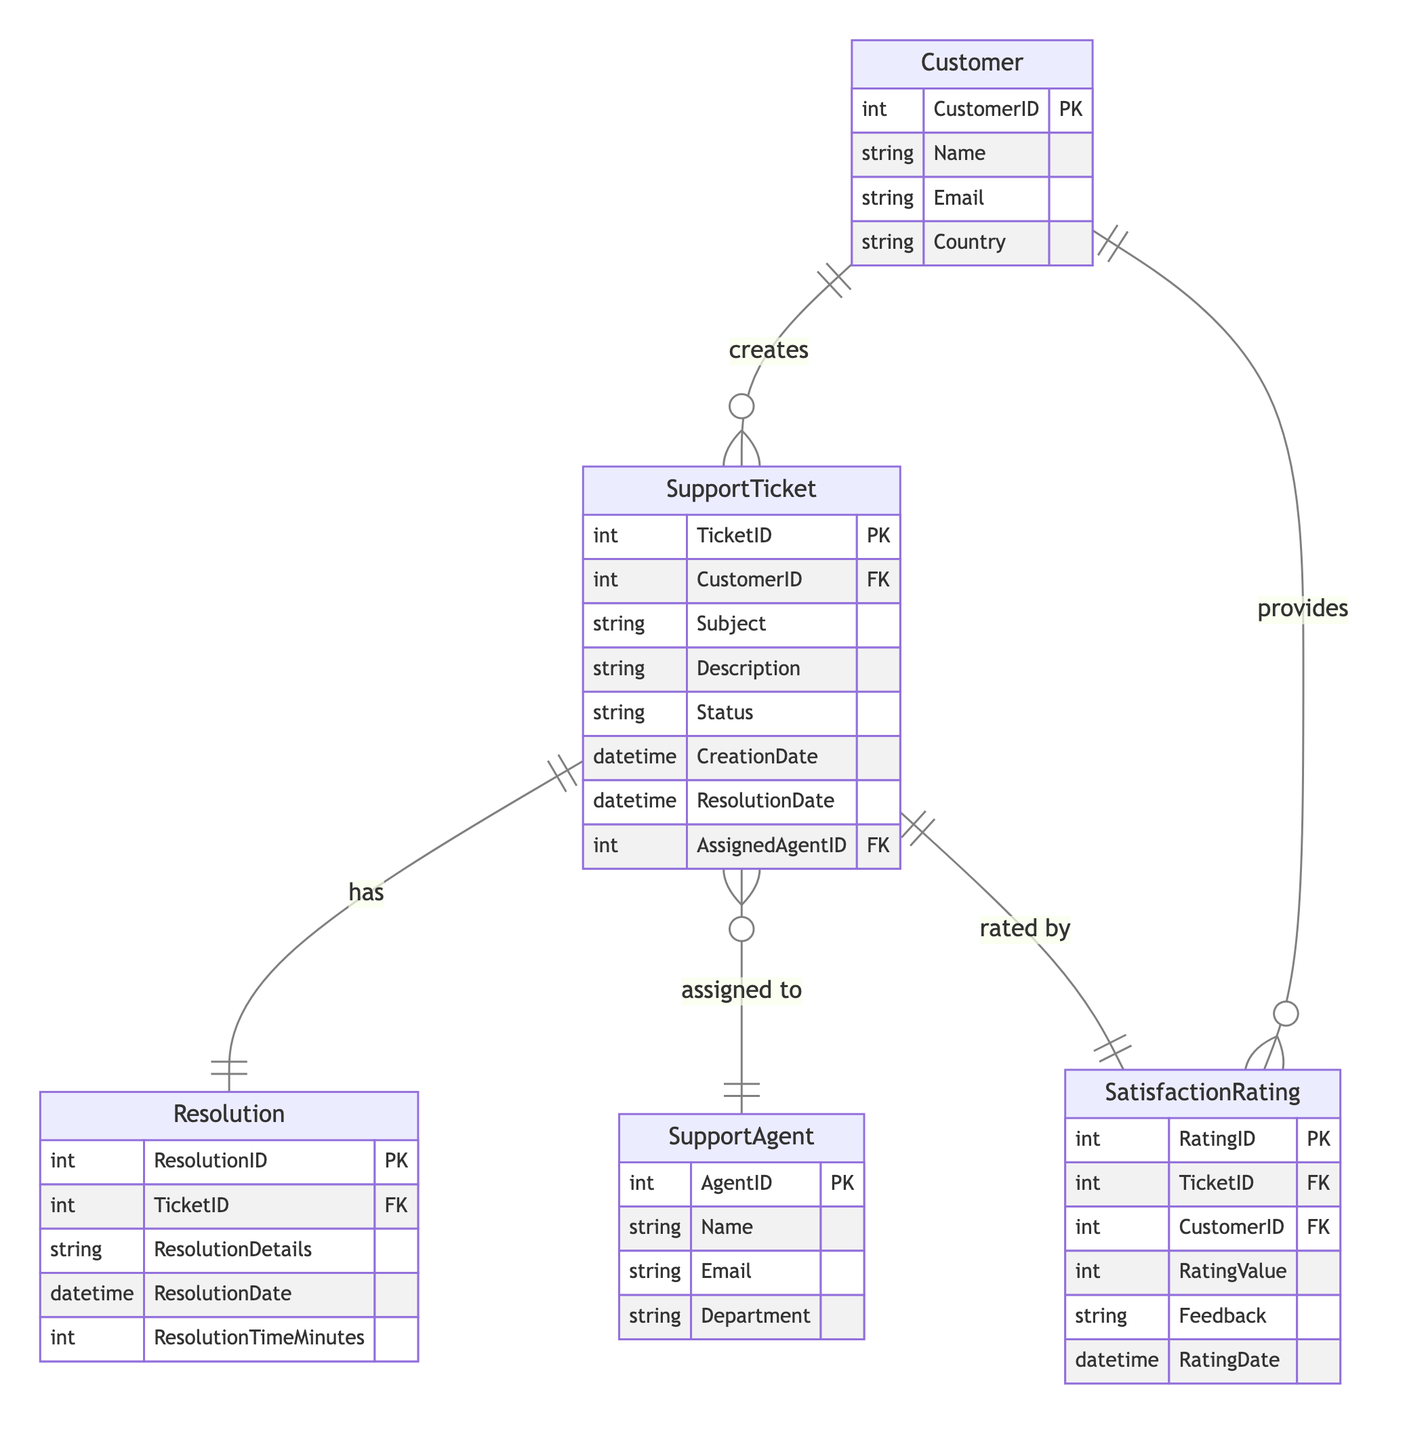What is the primary key of the Customer entity? The primary key for the Customer entity is the CustomerID, which uniquely identifies each customer in the database.
Answer: CustomerID How many entities are there in this diagram? The diagram includes five entities: Customer, SupportTicket, SupportAgent, Resolution, and SatisfactionRating. Therefore, the total number is five.
Answer: Five What type of relationship exists between SupportTicket and Resolution? The relationship between SupportTicket and Resolution is One-to-One, indicating that each support ticket corresponds to exactly one resolution.
Answer: One-to-One How many support tickets can be created by a single customer? A customer can create multiple support tickets, as indicated by the One-to-Many relationship between Customer and SupportTicket.
Answer: Multiple Which entity is assigned to support tickets? SupportAgent is the entity assigned to support tickets, as shown by the relationship between SupportTicket and SupportAgent.
Answer: SupportAgent What attribute measures the time taken to resolve a support ticket? The attribute that measures the time taken to resolve a support ticket is ResolutionTimeMinutes, found within the Resolution entity.
Answer: ResolutionTimeMinutes Can a customer give ratings for multiple support tickets? Yes, a customer can provide multiple satisfaction ratings for different support tickets, as indicated by the One-to-Many relationship between Customer and SatisfactionRating.
Answer: Yes What type of relationship exists between SatisfactionRating and SupportTicket? The relationship between SatisfactionRating and SupportTicket is One-to-One, meaning each support ticket has one associated satisfaction rating.
Answer: One-to-One Which entity has the attribute "Department"? The SupportAgent entity has the attribute "Department," which specifies the department to which the agent belongs.
Answer: SupportAgent 